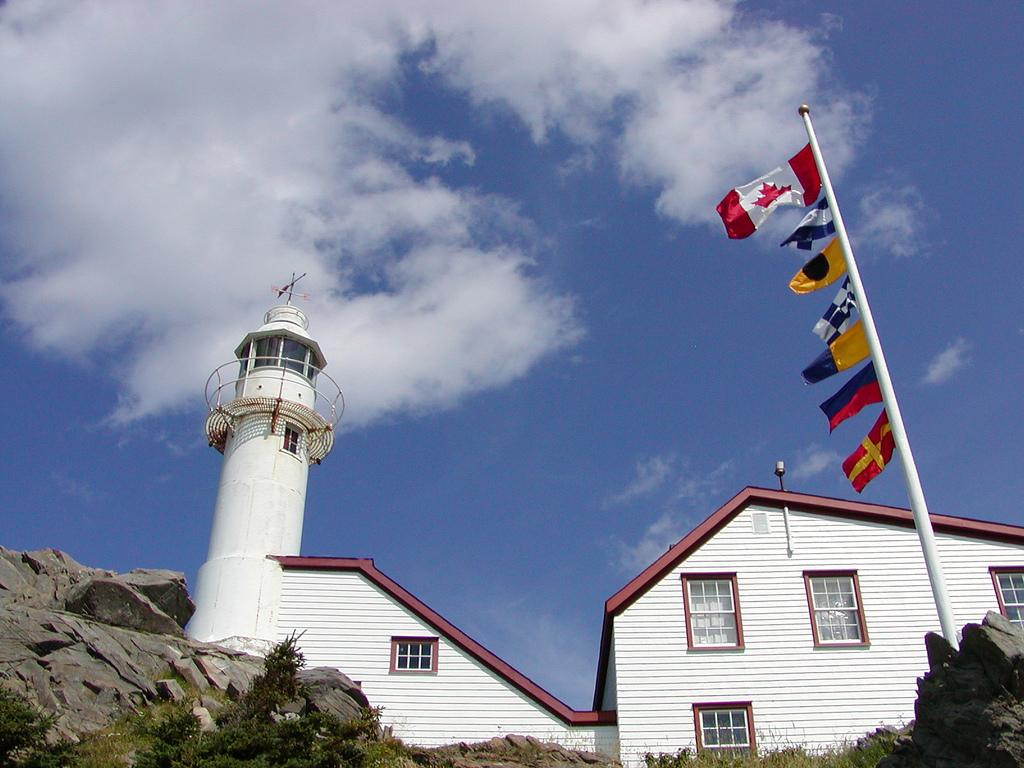What type of structure is present in the image? There is a building in the image. Can you describe the appearance of the building? The building is white. What else can be seen in the image besides the building? There are flags on poles in the image. How would you describe the flags? The flags are multi-colored. What can be seen in the background of the image? The sky is visible in the image. How would you describe the color of the sky? The sky has a combination of white and blue colors. How many monkeys are sitting on the roof of the building in the image? There are no monkeys present in the image; it only features a building, flags, and the sky. What is the rate of snowfall in the image? There is no snowfall mentioned or depicted in the image, and the weather conditions cannot be determined from the provided facts. 